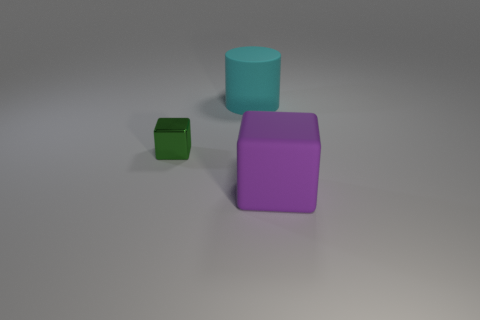Describe the lighting and setting of where these objects are placed. The objects are placed on a flat, even surface that appears to be under soft, diffused lighting. The shadows are subtle, indicating the light source is not highly directional, and the background is plain and uncluttered, providing a neutral setting that brings focus to the shapes and colors of the objects. 